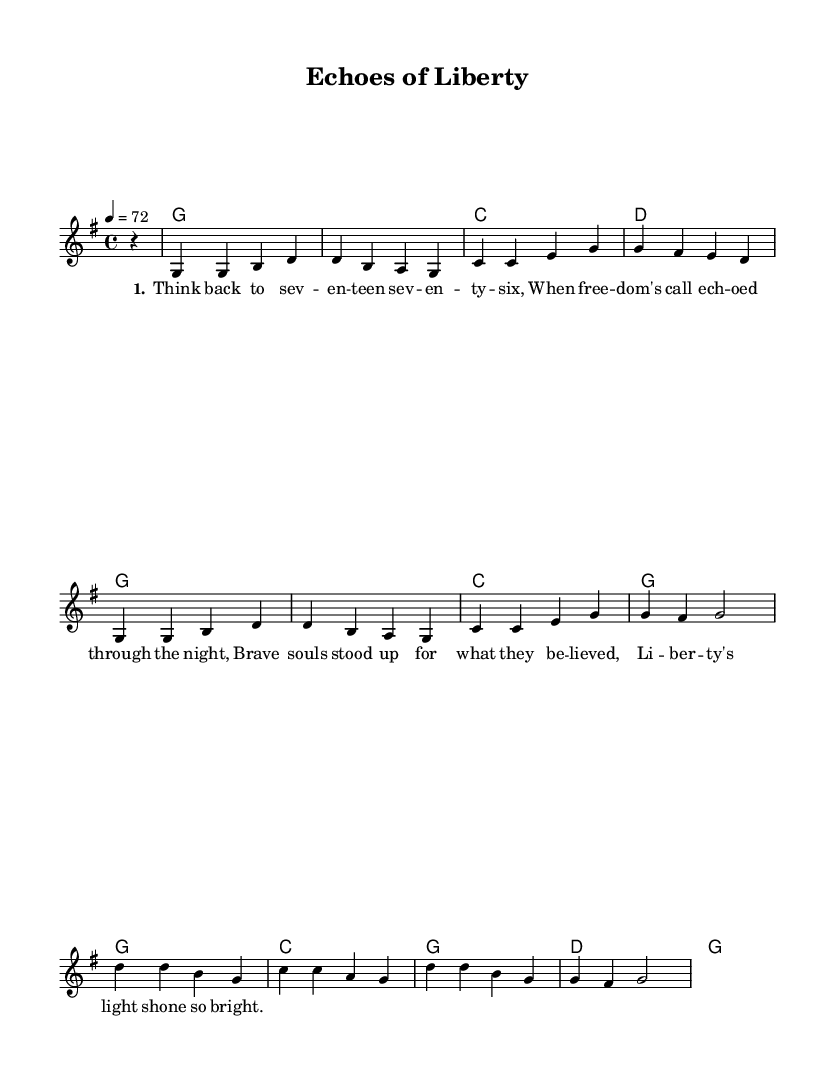What is the key signature of this music? The key signature is indicated by the number of sharps or flats at the beginning of the staff. In this case, there are no sharps or flats shown, which means the key is G major.
Answer: G major What is the time signature of this music? The time signature is represented in the staff notation at the beginning. Here, it is shown as 4/4, meaning there are 4 beats in a measure and the quarter note gets one beat.
Answer: 4/4 What is the tempo marking of the piece? The tempo marking is shown above the staff, which indicates how fast the music should be played. The marking here is "4 = 72", meaning a quarter note should be played at 72 beats per minute.
Answer: 72 What is the first note of the melody? The first note of the melody is shown in the staff as a notehead. By checking the first measure, the note is G.
Answer: G How many measures are in the melody? By counting the measures from the `melody` section shown, there are a total of 8 measures including the partial measure at the beginning.
Answer: 8 What is the overall mood reflected in the lyrics? The lyrics speak about reflecting on a historical event and the theme of freedom and bravery. The words convey a sentimental and nostalgic mood. This aligns with typical themes in country rock music.
Answer: Nostalgic What historical event does the song seem to reference? The lyrics hint at an important moment in American history, specifically referencing the year "seventeen seventy-six," which relates to the American Declaration of Independence. This context indicates a reflection on the pursuit of liberty and historical patriotism.
Answer: American Revolution 